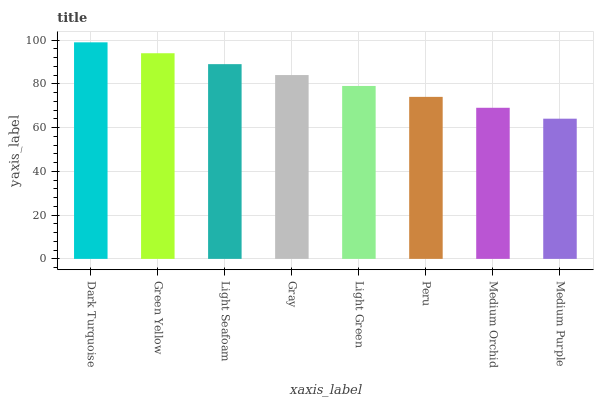Is Medium Purple the minimum?
Answer yes or no. Yes. Is Dark Turquoise the maximum?
Answer yes or no. Yes. Is Green Yellow the minimum?
Answer yes or no. No. Is Green Yellow the maximum?
Answer yes or no. No. Is Dark Turquoise greater than Green Yellow?
Answer yes or no. Yes. Is Green Yellow less than Dark Turquoise?
Answer yes or no. Yes. Is Green Yellow greater than Dark Turquoise?
Answer yes or no. No. Is Dark Turquoise less than Green Yellow?
Answer yes or no. No. Is Gray the high median?
Answer yes or no. Yes. Is Light Green the low median?
Answer yes or no. Yes. Is Peru the high median?
Answer yes or no. No. Is Light Seafoam the low median?
Answer yes or no. No. 